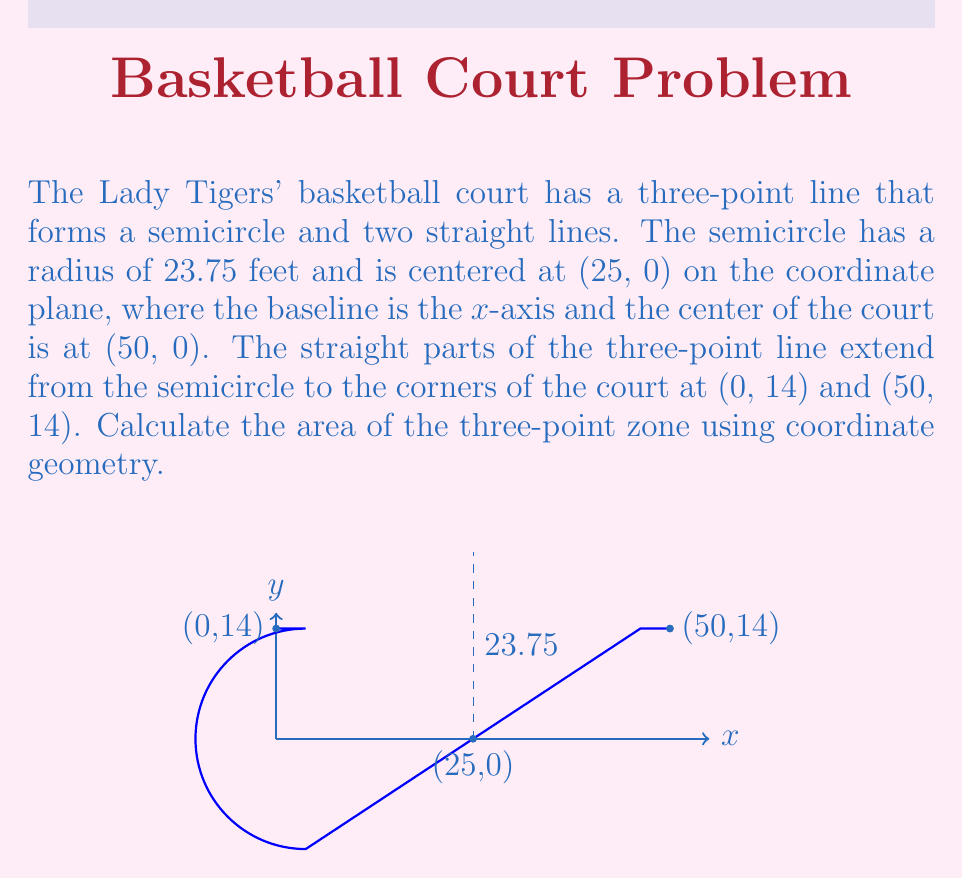Could you help me with this problem? Let's break this down step-by-step:

1) The area of the three-point zone can be calculated by subtracting the area of the semicircle from the area of the rectangle.

2) Area of the rectangle:
   $A_{rectangle} = 50 \times 14 = 700$ sq ft

3) Area of the semicircle:
   $A_{semicircle} = \frac{1}{2} \pi r^2$
   Where $r = 23.75$ ft
   $A_{semicircle} = \frac{1}{2} \pi (23.75)^2 = 886.73$ sq ft

4) Area of the three-point zone:
   $A_{zone} = A_{rectangle} - A_{semicircle}$
   $A_{zone} = 700 - 886.73 = -186.73$ sq ft

5) However, this negative result means we've subtracted too much. We need to add back the areas of the two small segments at the corners.

6) Each corner segment is a right triangle. The base of this triangle is the difference between the court width (50 ft) and the diameter of the semicircle (47.5 ft), divided by 2:
   $base = \frac{50 - 47.5}{2} = 1.25$ ft

7) The height of each triangle is 14 ft.

8) Area of each triangle:
   $A_{triangle} = \frac{1}{2} \times 1.25 \times 14 = 8.75$ sq ft

9) Total area to add back:
   $A_{corners} = 2 \times 8.75 = 17.5$ sq ft

10) Final area of the three-point zone:
    $A_{final} = 700 - 886.73 + 17.5 = -169.23$ sq ft

11) Taking the absolute value (since area is always positive):
    $A_{final} = 169.23$ sq ft
Answer: $$169.23 \text{ sq ft}$$ 